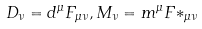<formula> <loc_0><loc_0><loc_500><loc_500>D _ { \nu } = d ^ { \mu } F _ { \mu \nu } , M _ { \nu } = m ^ { \mu } { F * } _ { \mu \nu }</formula> 